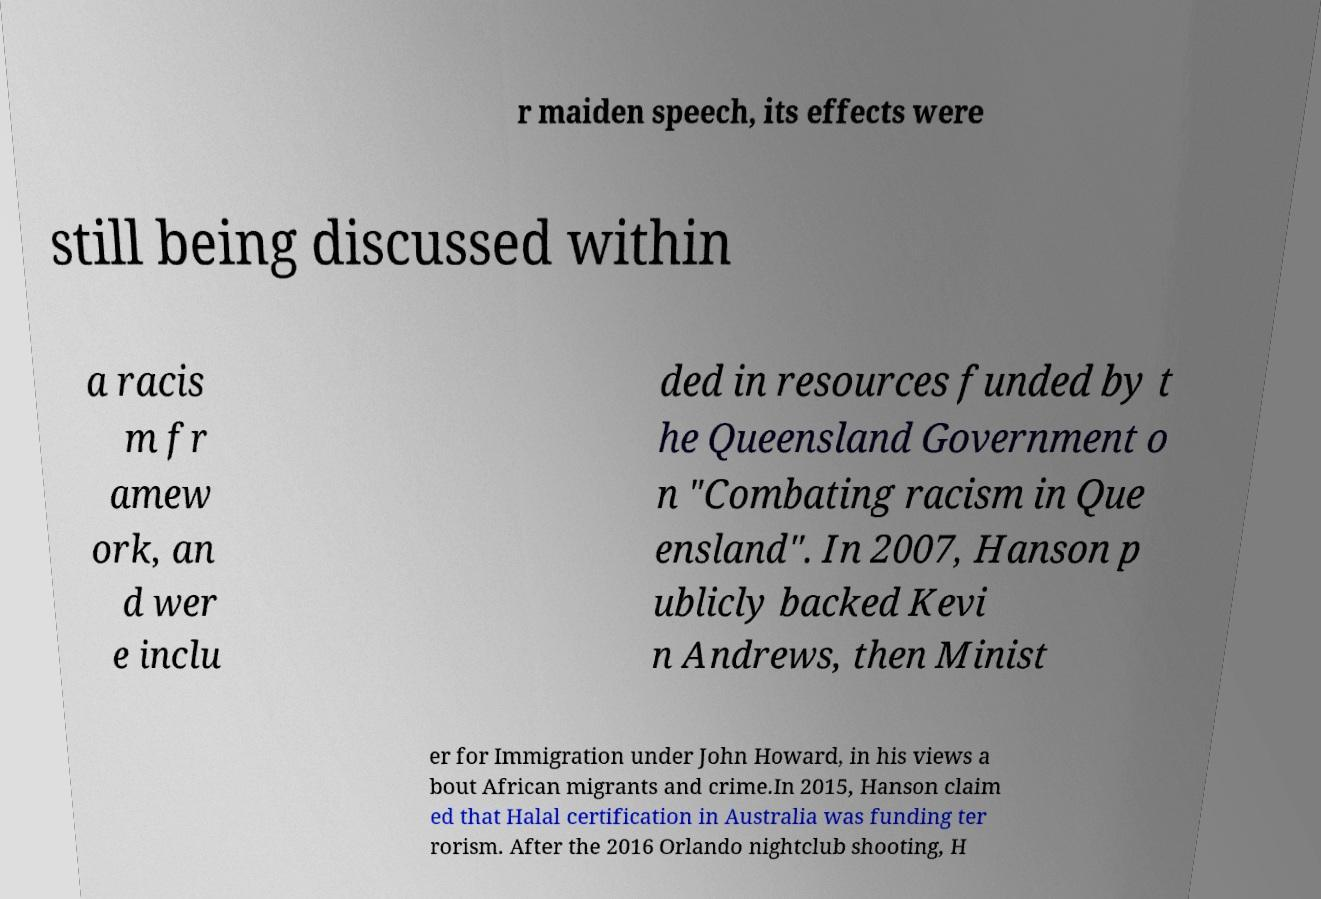There's text embedded in this image that I need extracted. Can you transcribe it verbatim? r maiden speech, its effects were still being discussed within a racis m fr amew ork, an d wer e inclu ded in resources funded by t he Queensland Government o n "Combating racism in Que ensland". In 2007, Hanson p ublicly backed Kevi n Andrews, then Minist er for Immigration under John Howard, in his views a bout African migrants and crime.In 2015, Hanson claim ed that Halal certification in Australia was funding ter rorism. After the 2016 Orlando nightclub shooting, H 